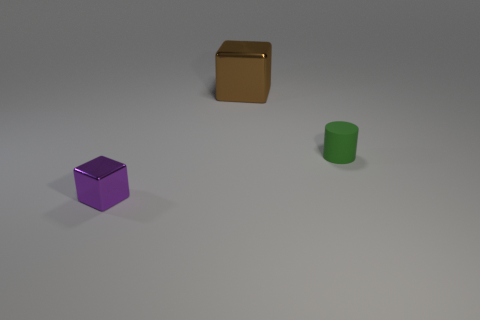How many metal things are either tiny cylinders or brown objects?
Provide a short and direct response. 1. Are there fewer matte objects that are left of the purple block than large brown balls?
Your answer should be very brief. No. What shape is the shiny thing in front of the block to the right of the tiny object in front of the tiny rubber cylinder?
Offer a terse response. Cube. Is the number of small green rubber objects greater than the number of metallic blocks?
Keep it short and to the point. No. How many other things are there of the same material as the cylinder?
Provide a short and direct response. 0. What number of objects are green metallic balls or metallic blocks left of the large metallic object?
Your answer should be very brief. 1. Are there fewer rubber things than cyan metallic objects?
Your answer should be very brief. No. What is the color of the metallic cube that is right of the metal cube that is in front of the thing that is on the right side of the large shiny block?
Offer a terse response. Brown. Are the tiny purple thing and the large thing made of the same material?
Provide a short and direct response. Yes. What number of purple metallic cubes are behind the small green object?
Ensure brevity in your answer.  0. 